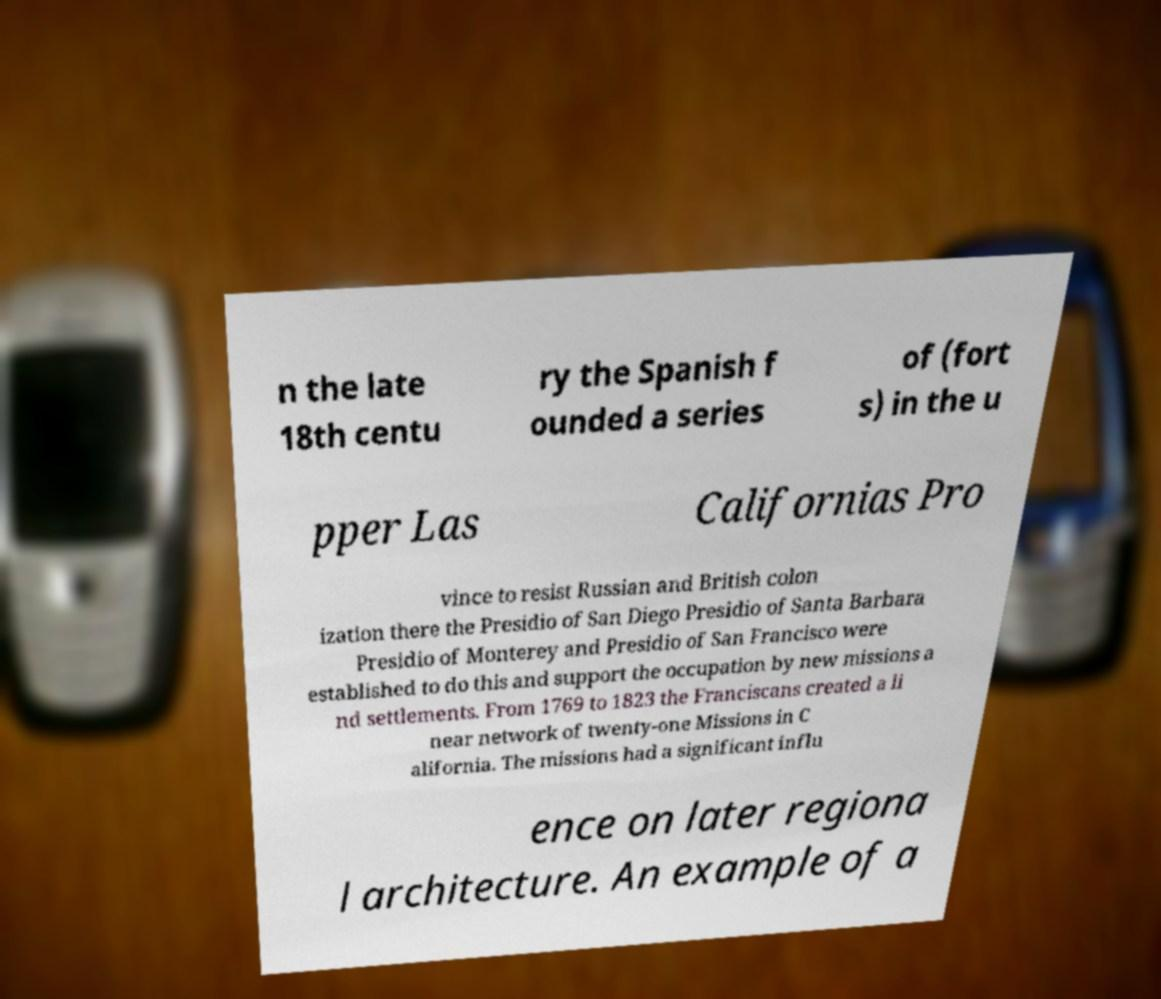There's text embedded in this image that I need extracted. Can you transcribe it verbatim? n the late 18th centu ry the Spanish f ounded a series of (fort s) in the u pper Las Californias Pro vince to resist Russian and British colon ization there the Presidio of San Diego Presidio of Santa Barbara Presidio of Monterey and Presidio of San Francisco were established to do this and support the occupation by new missions a nd settlements. From 1769 to 1823 the Franciscans created a li near network of twenty-one Missions in C alifornia. The missions had a significant influ ence on later regiona l architecture. An example of a 